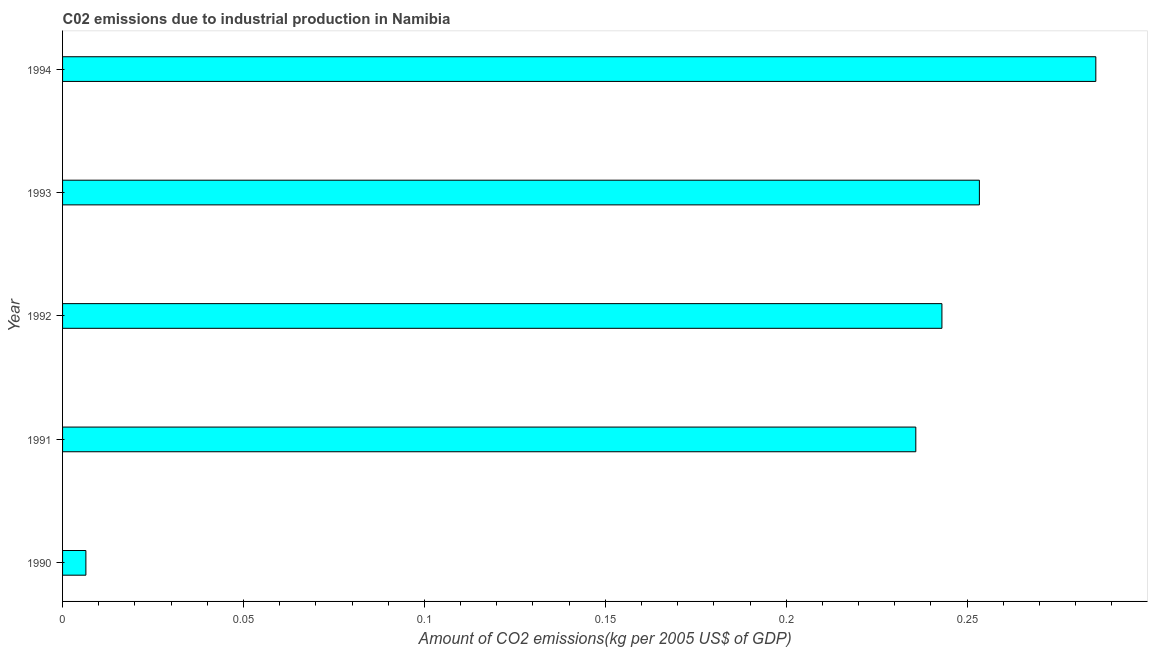Does the graph contain any zero values?
Ensure brevity in your answer.  No. Does the graph contain grids?
Make the answer very short. No. What is the title of the graph?
Your answer should be compact. C02 emissions due to industrial production in Namibia. What is the label or title of the X-axis?
Your response must be concise. Amount of CO2 emissions(kg per 2005 US$ of GDP). What is the label or title of the Y-axis?
Provide a succinct answer. Year. What is the amount of co2 emissions in 1994?
Your response must be concise. 0.29. Across all years, what is the maximum amount of co2 emissions?
Your answer should be compact. 0.29. Across all years, what is the minimum amount of co2 emissions?
Offer a terse response. 0.01. What is the sum of the amount of co2 emissions?
Ensure brevity in your answer.  1.02. What is the difference between the amount of co2 emissions in 1991 and 1993?
Ensure brevity in your answer.  -0.02. What is the average amount of co2 emissions per year?
Your response must be concise. 0.2. What is the median amount of co2 emissions?
Provide a short and direct response. 0.24. Do a majority of the years between 1991 and 1992 (inclusive) have amount of co2 emissions greater than 0.27 kg per 2005 US$ of GDP?
Provide a succinct answer. No. What is the ratio of the amount of co2 emissions in 1991 to that in 1994?
Keep it short and to the point. 0.83. What is the difference between the highest and the second highest amount of co2 emissions?
Make the answer very short. 0.03. What is the difference between the highest and the lowest amount of co2 emissions?
Ensure brevity in your answer.  0.28. Are all the bars in the graph horizontal?
Make the answer very short. Yes. What is the difference between two consecutive major ticks on the X-axis?
Give a very brief answer. 0.05. Are the values on the major ticks of X-axis written in scientific E-notation?
Provide a short and direct response. No. What is the Amount of CO2 emissions(kg per 2005 US$ of GDP) in 1990?
Your response must be concise. 0.01. What is the Amount of CO2 emissions(kg per 2005 US$ of GDP) in 1991?
Your answer should be compact. 0.24. What is the Amount of CO2 emissions(kg per 2005 US$ of GDP) in 1992?
Offer a very short reply. 0.24. What is the Amount of CO2 emissions(kg per 2005 US$ of GDP) of 1993?
Offer a terse response. 0.25. What is the Amount of CO2 emissions(kg per 2005 US$ of GDP) in 1994?
Make the answer very short. 0.29. What is the difference between the Amount of CO2 emissions(kg per 2005 US$ of GDP) in 1990 and 1991?
Offer a very short reply. -0.23. What is the difference between the Amount of CO2 emissions(kg per 2005 US$ of GDP) in 1990 and 1992?
Your answer should be very brief. -0.24. What is the difference between the Amount of CO2 emissions(kg per 2005 US$ of GDP) in 1990 and 1993?
Provide a short and direct response. -0.25. What is the difference between the Amount of CO2 emissions(kg per 2005 US$ of GDP) in 1990 and 1994?
Make the answer very short. -0.28. What is the difference between the Amount of CO2 emissions(kg per 2005 US$ of GDP) in 1991 and 1992?
Ensure brevity in your answer.  -0.01. What is the difference between the Amount of CO2 emissions(kg per 2005 US$ of GDP) in 1991 and 1993?
Your response must be concise. -0.02. What is the difference between the Amount of CO2 emissions(kg per 2005 US$ of GDP) in 1991 and 1994?
Ensure brevity in your answer.  -0.05. What is the difference between the Amount of CO2 emissions(kg per 2005 US$ of GDP) in 1992 and 1993?
Offer a very short reply. -0.01. What is the difference between the Amount of CO2 emissions(kg per 2005 US$ of GDP) in 1992 and 1994?
Offer a very short reply. -0.04. What is the difference between the Amount of CO2 emissions(kg per 2005 US$ of GDP) in 1993 and 1994?
Provide a succinct answer. -0.03. What is the ratio of the Amount of CO2 emissions(kg per 2005 US$ of GDP) in 1990 to that in 1991?
Offer a terse response. 0.03. What is the ratio of the Amount of CO2 emissions(kg per 2005 US$ of GDP) in 1990 to that in 1992?
Keep it short and to the point. 0.03. What is the ratio of the Amount of CO2 emissions(kg per 2005 US$ of GDP) in 1990 to that in 1993?
Provide a short and direct response. 0.03. What is the ratio of the Amount of CO2 emissions(kg per 2005 US$ of GDP) in 1990 to that in 1994?
Provide a short and direct response. 0.02. What is the ratio of the Amount of CO2 emissions(kg per 2005 US$ of GDP) in 1991 to that in 1994?
Give a very brief answer. 0.83. What is the ratio of the Amount of CO2 emissions(kg per 2005 US$ of GDP) in 1992 to that in 1994?
Your answer should be compact. 0.85. What is the ratio of the Amount of CO2 emissions(kg per 2005 US$ of GDP) in 1993 to that in 1994?
Provide a succinct answer. 0.89. 